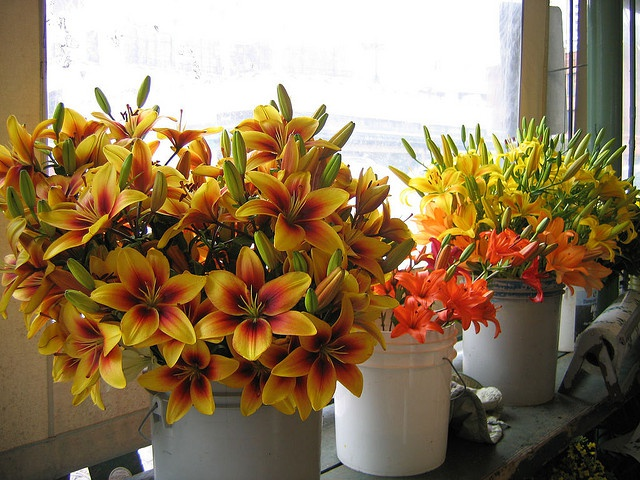Describe the objects in this image and their specific colors. I can see potted plant in gray, olive, maroon, and black tones, potted plant in gray, black, olive, and maroon tones, potted plant in gray, brown, and darkgray tones, vase in gray, darkgray, and lightgray tones, and vase in gray and black tones in this image. 